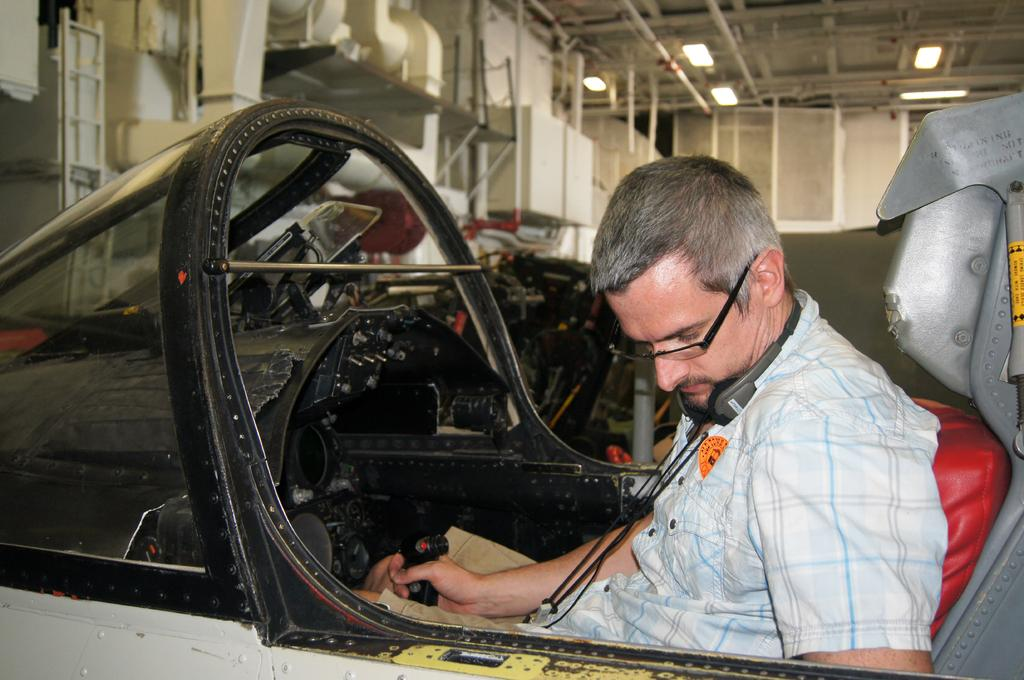What is the person in the image doing? The person is sitting inside a vehicle. What is the person holding in the image? The person is holding a black object. What can be seen in the background of the image? There are lights, rods, pipes, and other objects in the background of the image. What type of pest can be seen crawling on the curtain in the image? There is no curtain present in the image, and therefore no pest can be seen crawling on it. 